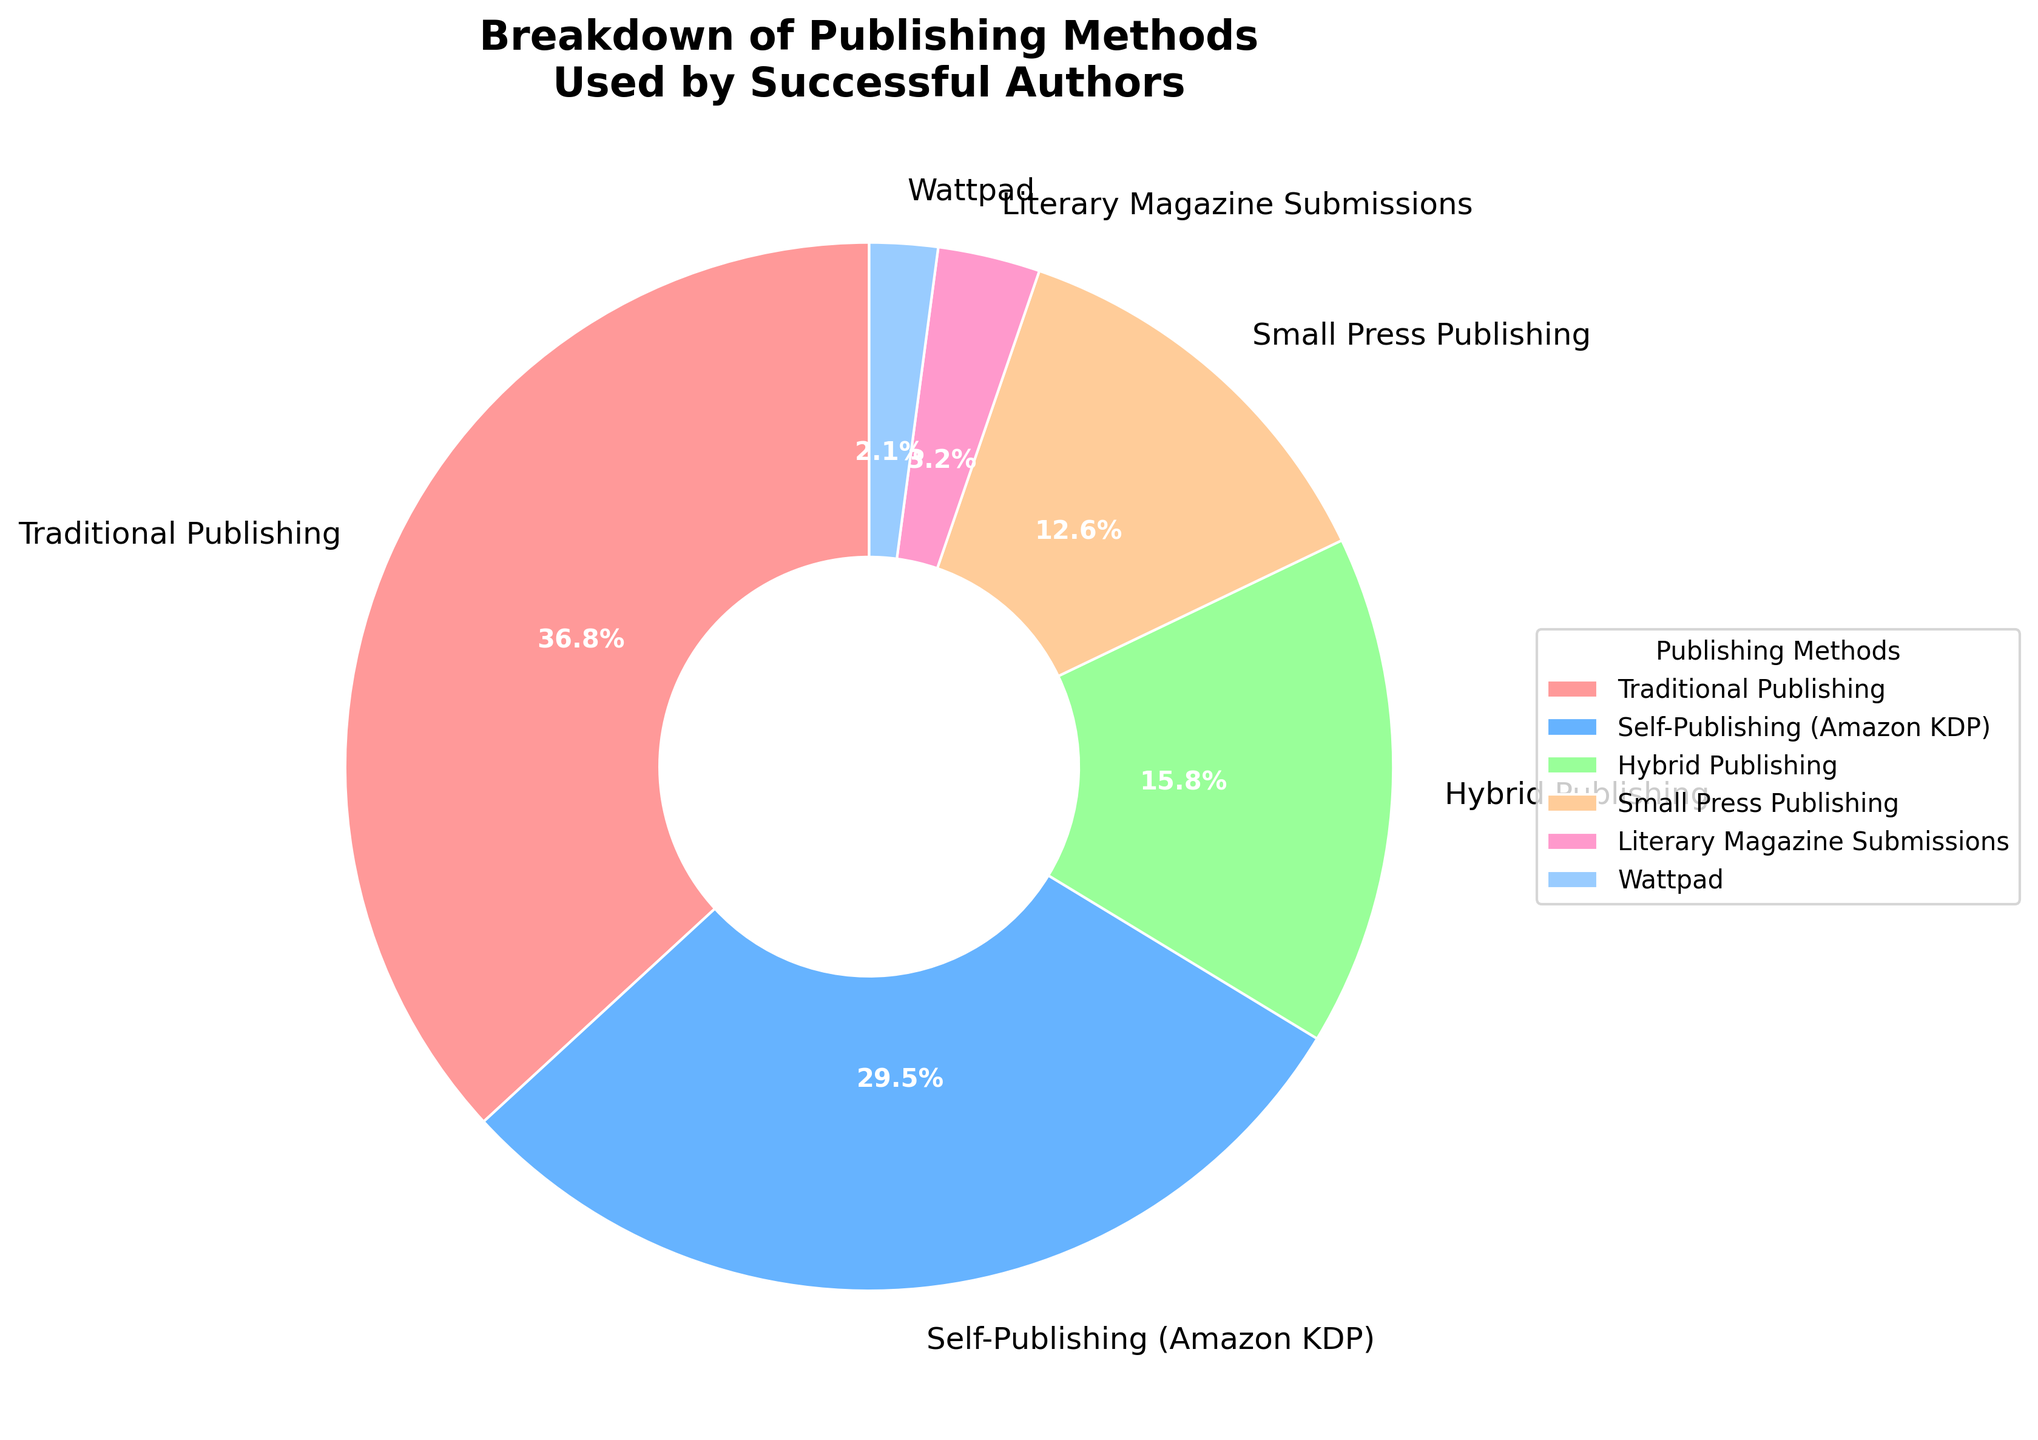What's the most commonly used publishing method? The pie chart indicates percentages for different publishing methods. The largest segment, representing 35%, is for Traditional Publishing. Therefore, Traditional Publishing is the most commonly used method among successful authors in the group.
Answer: Traditional Publishing What percentage of authors used self-publishing services like Amazon KDP? The pie chart clearly labels each publishing method and its corresponding percentage. The segment for Self-Publishing (Amazon KDP) is marked at 28%.
Answer: 28% How does the percentage of authors using hybrid publishing compare to those using small press publishing? The pie chart shows Hybrid Publishing at 15% and Small Press Publishing at 12%. Consequently, Hybrid Publishing is greater by 3 percentage points.
Answer: Hybrid Publishing is 3% higher What is the total percentage of authors using the less traditional methods (Small Press Publishing, Literary Magazine Submissions, Wattpad)? The percentages are given as follows: Small Press Publishing (12%), Literary Magazine Submissions (3%), Wattpad (2%). Adding these values gives 12 + 3 + 2 = 17%.
Answer: 17% Which publishing method has the smallest representation among successful authors in the group? The pie chart labels indicate that Wattpad has the smallest segment, representing 2% of the total.
Answer: Wattpad How much more popular is Traditional Publishing than Literary Magazine Submissions? The pie chart shows Traditional Publishing at 35% and Literary Magazine Submissions at 3%. Subtracting gives 35% - 3% = 32%.
Answer: 32% How does the combined percentage of Self-Publishing (Amazon KDP) and Hybrid Publishing compare to Traditional Publishing? Adding the percentages for Self-Publishing (Amazon KDP) and Hybrid Publishing gives 28% + 15% = 43%. Comparing this to Traditional Publishing's 35%, 43% is higher by 8 percentage points.
Answer: 8% higher Between Hybrid Publishing and Small Press Publishing, which is more commonly used and by what margin? The chart indicates Hybrid Publishing is at 15% and Small Press Publishing is at 12%. Thus, Hybrid Publishing is more common by 3 percentage points.
Answer: Hybrid Publishing by 3% Which three publishing methods account for the majority usage among successful authors? The pie chart indicates that Traditional Publishing (35%), Self-Publishing (Amazon KDP) (28%), and Hybrid Publishing (15%), together add up to 35% + 28% + 15% = 78%, a clear majority.
Answer: Traditional Publishing, Self-Publishing (Amazon KDP), Hybrid Publishing What is the difference in percentage between the second and third most popular publishing methods? The second most popular method is Self-Publishing (Amazon KDP) at 28% and the third is Hybrid Publishing at 15%. The difference is 28% - 15% = 13%.
Answer: 13% 